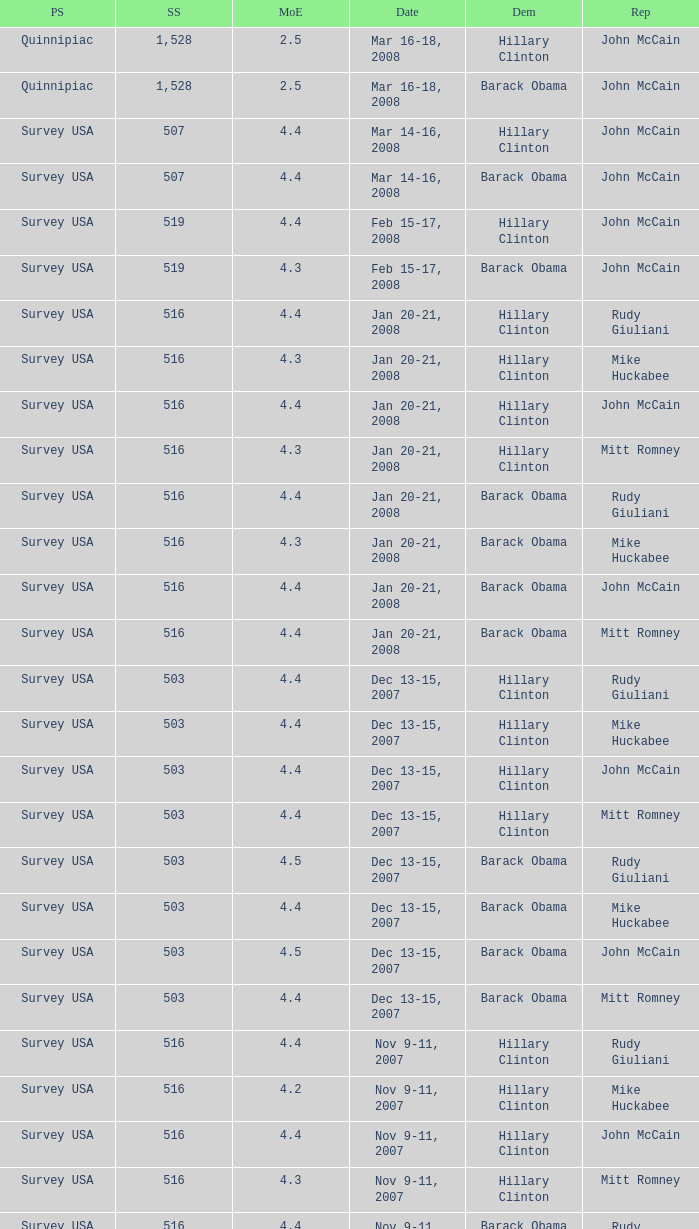What was the date of the poll with a sample size of 496 where Republican Mike Huckabee was chosen? Oct 12-14, 2007. 